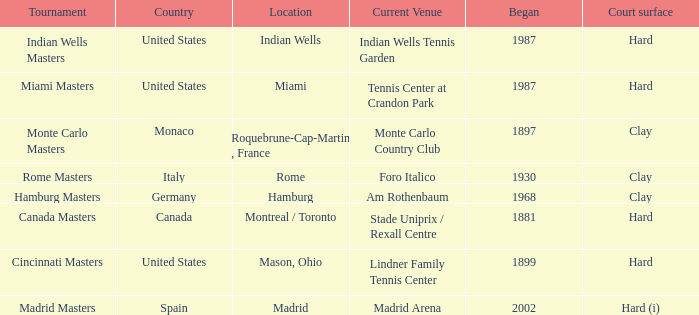What year was the tournament first held in Italy? 1930.0. 